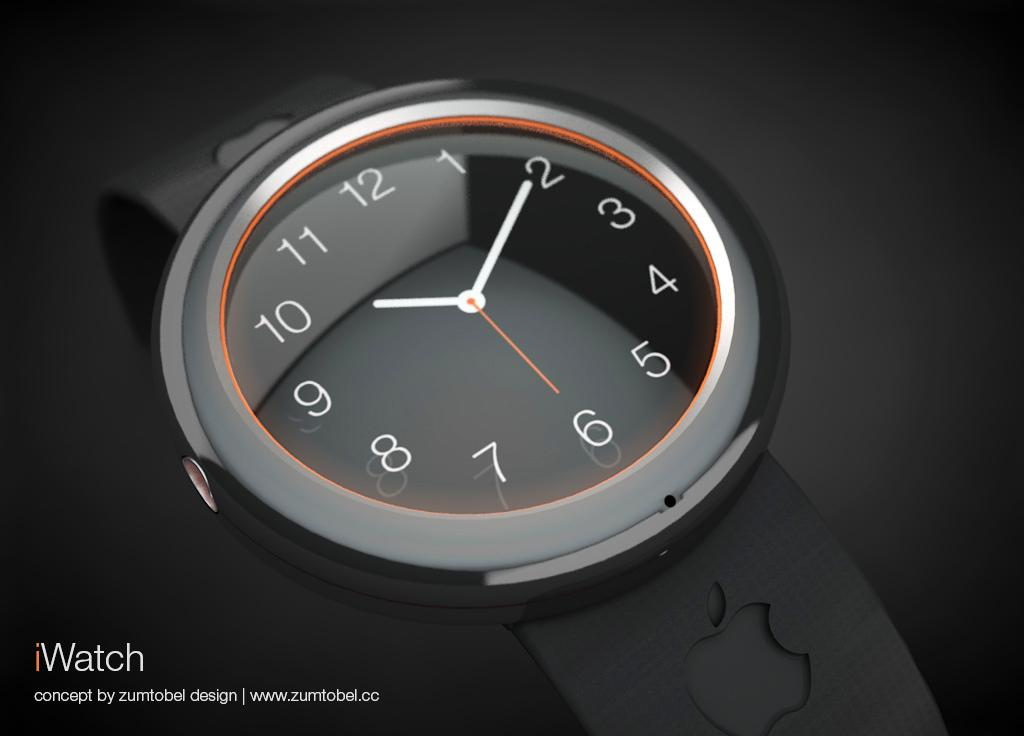<image>
Give a short and clear explanation of the subsequent image. A photo of a black watch that is labeled I Watch. 